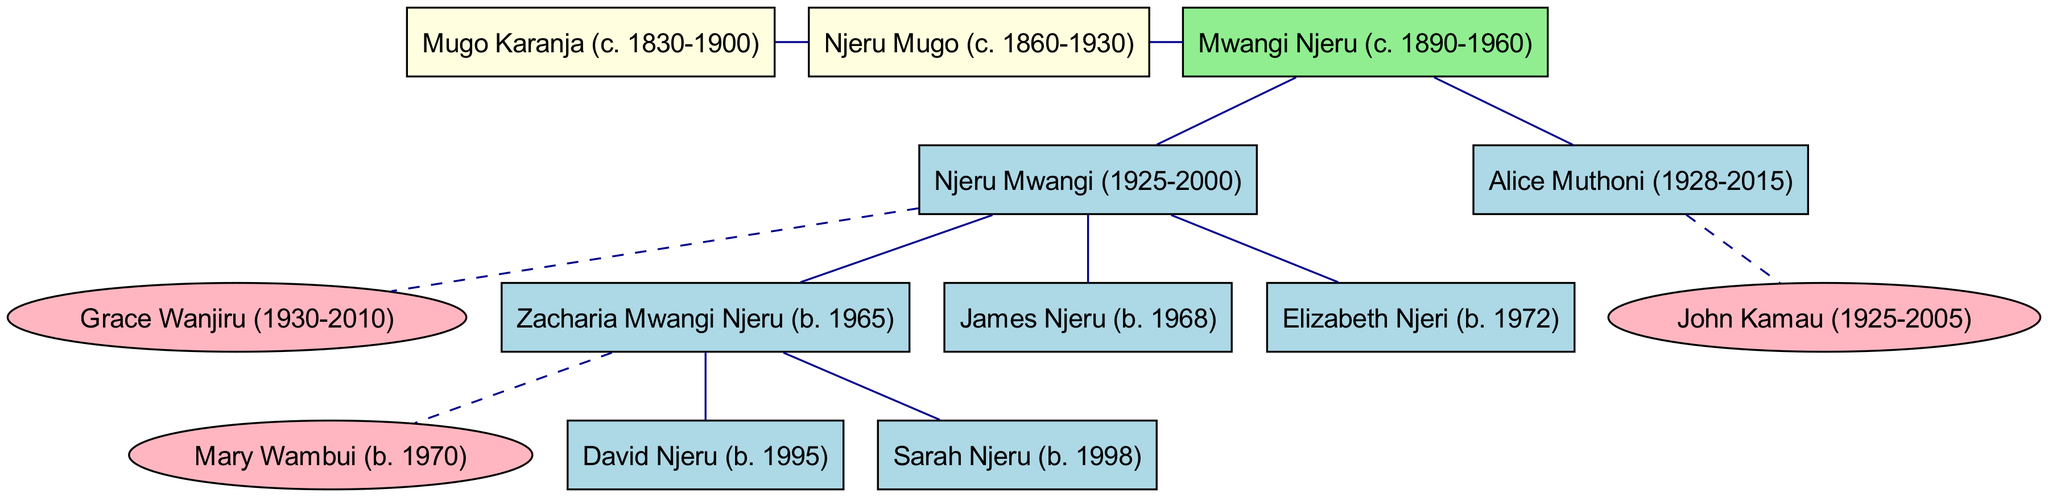What is the name of Zacharia Mwangi Njeru's spouse? The diagram indicates that Zacharia Mwangi Njeru is married to Mary Wambui. This information can be found directly under Zacharia in the graph as "spouse."
Answer: Mary Wambui How many children did Njeru Mwangi have? Njeru Mwangi has three children listed: Zacharia Mwangi, James Njeru, and Elizabeth Njeri. This number is derived from counting each child entity directly under Njeru Mwangi's node.
Answer: 3 Who are the ancestors of Mwangi Njeru? The ancestors of Mwangi Njeru are Njeru Mugo and Mugo Karanja, which are represented in the diagram above the root node and linked to it.
Answer: Njeru Mugo, Mugo Karanja What year did Alice Muthoni pass away? The diagram shows that Alice Muthoni died in the year 2015. This information is clearly stated next to her name.
Answer: 2015 How is Zacharia Mwangi Njeru related to Njeru Mwangi? Zacharia Mwangi Njeru is the son of Njeru Mwangi, which can be determined by observing the tree structure where Zacharia is directly linked as a child under Njeru Mwangi.
Answer: Son How many spouses are shown in the family tree? The family tree displays a total of three spouses: Grace Wanjiru, Mary Wambui, and Alice Muthoni. This is derived from counting the nodes that have a "spouse" attribute.
Answer: 3 Which child of Njeru Mwangi was born in 1968? The diagram indicates that James Njeru was born in 1968, found by looking at the birth years listed next to each child under Njeru Mwangi.
Answer: James Njeru Which ancestor is most recent in the tree? The most recent ancestor depicted in the family tree is Njeru Mugo, who is noted to have lived from 1860 to 1930, positioned directly above the root node.
Answer: Njeru Mugo What is the relationship between Alice Muthoni and John Kamau? Alice Muthoni is the spouse of John Kamau as shown in the family tree, where both are linked together under the same node.
Answer: Spouses 